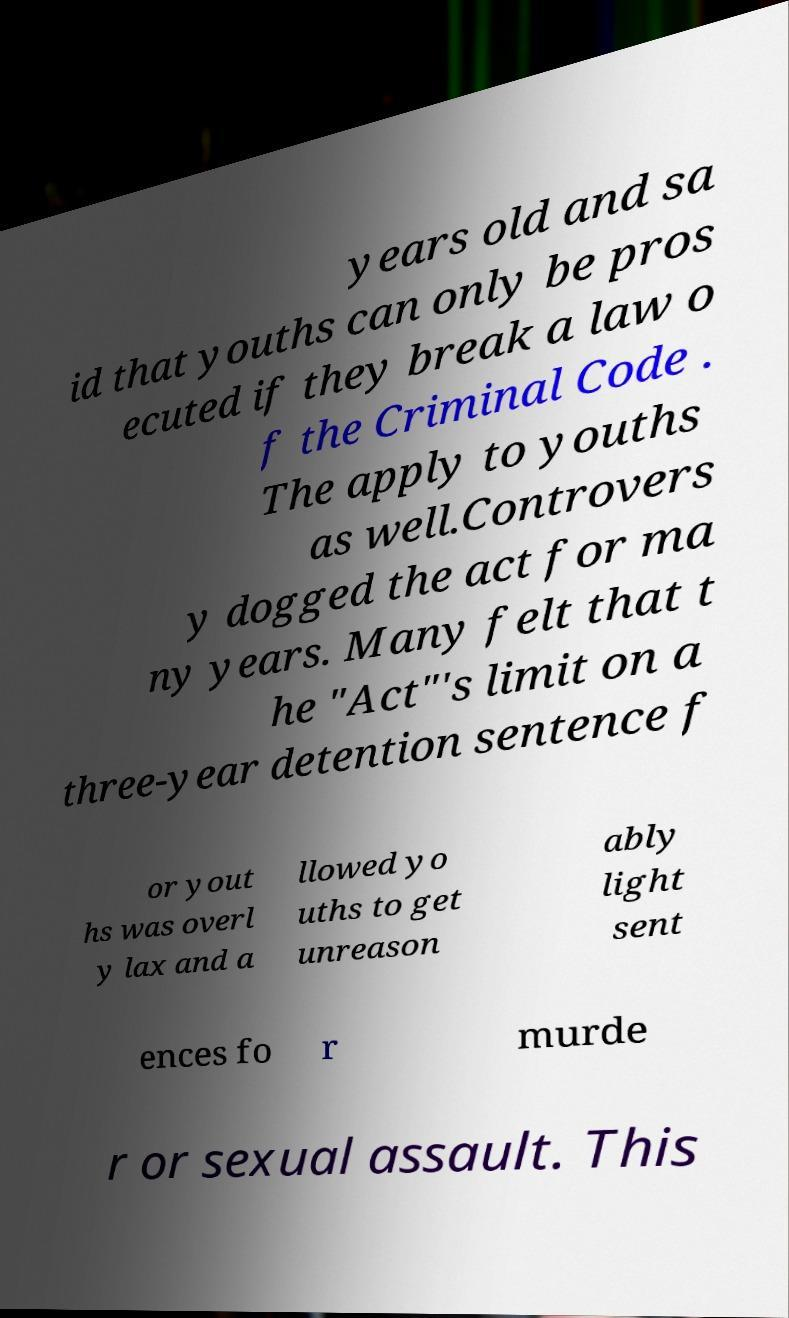Please read and relay the text visible in this image. What does it say? years old and sa id that youths can only be pros ecuted if they break a law o f the Criminal Code . The apply to youths as well.Controvers y dogged the act for ma ny years. Many felt that t he "Act"'s limit on a three-year detention sentence f or yout hs was overl y lax and a llowed yo uths to get unreason ably light sent ences fo r murde r or sexual assault. This 